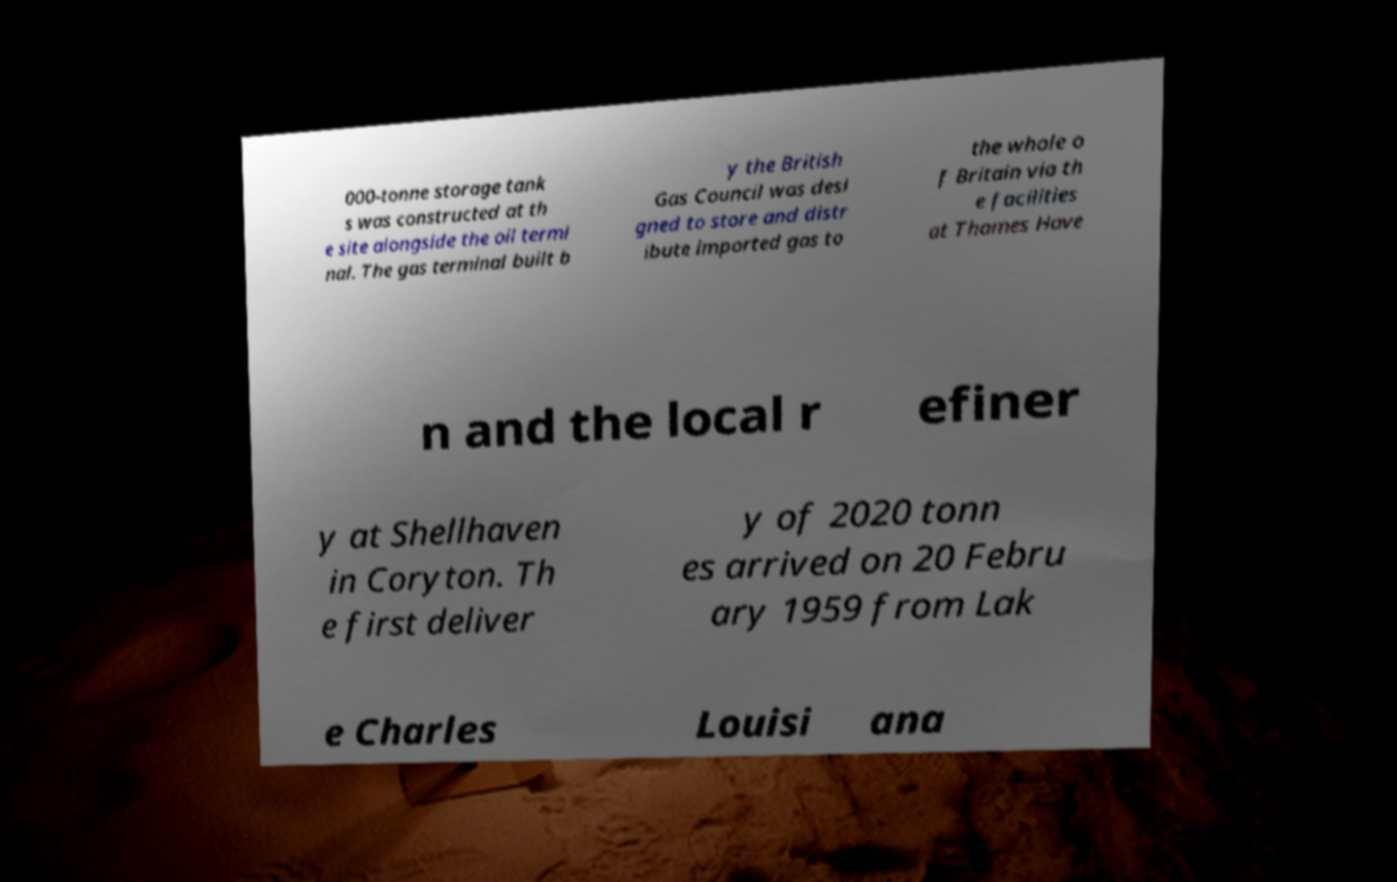I need the written content from this picture converted into text. Can you do that? 000-tonne storage tank s was constructed at th e site alongside the oil termi nal. The gas terminal built b y the British Gas Council was desi gned to store and distr ibute imported gas to the whole o f Britain via th e facilities at Thames Have n and the local r efiner y at Shellhaven in Coryton. Th e first deliver y of 2020 tonn es arrived on 20 Febru ary 1959 from Lak e Charles Louisi ana 